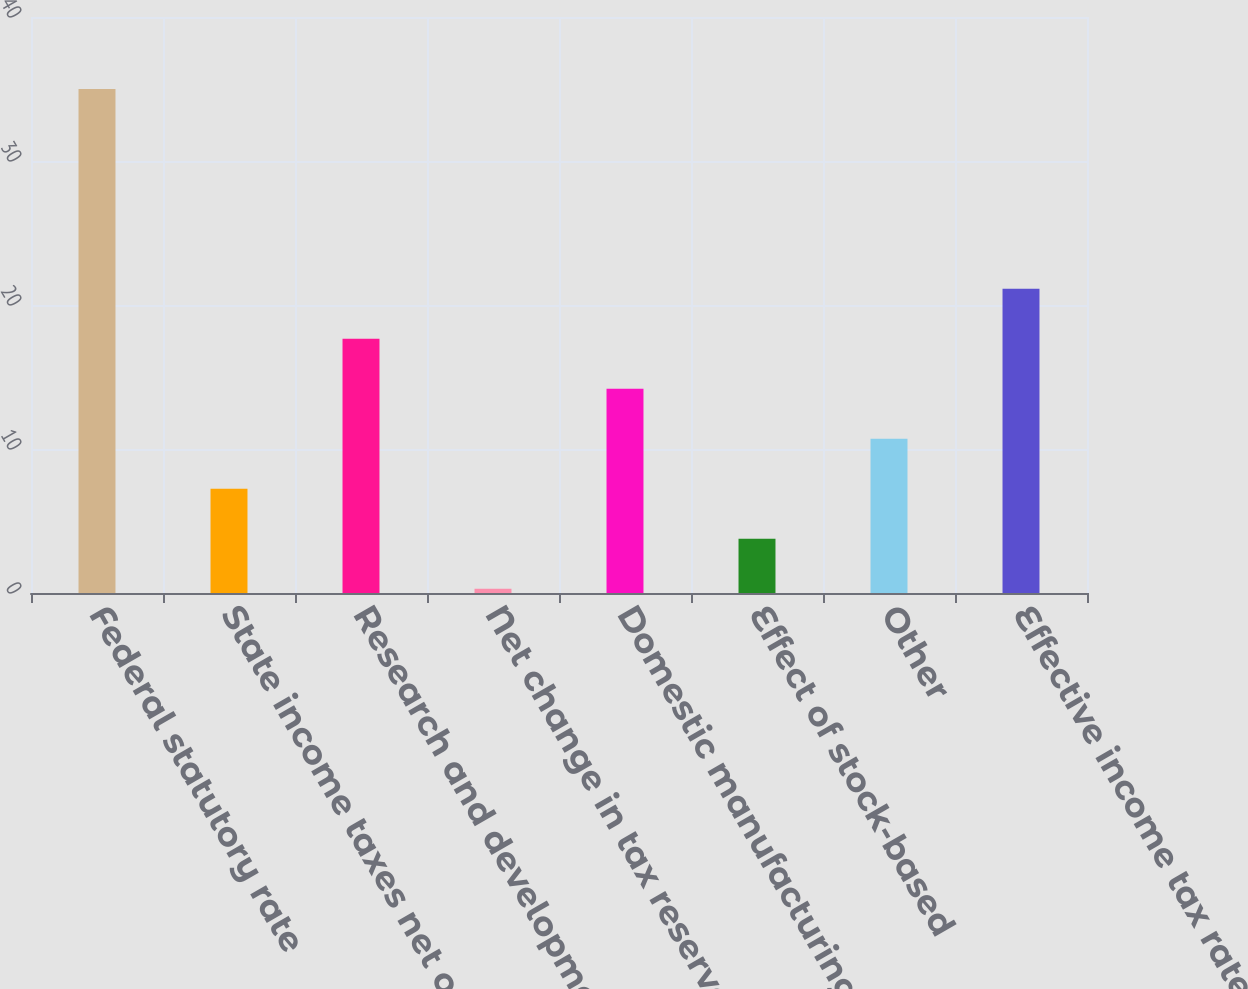Convert chart. <chart><loc_0><loc_0><loc_500><loc_500><bar_chart><fcel>Federal statutory rate<fcel>State income taxes net of<fcel>Research and development tax<fcel>Net change in tax reserves<fcel>Domestic manufacturing benefit<fcel>Effect of stock-based<fcel>Other<fcel>Effective income tax rate<nl><fcel>35<fcel>7.24<fcel>17.65<fcel>0.3<fcel>14.18<fcel>3.77<fcel>10.71<fcel>21.12<nl></chart> 